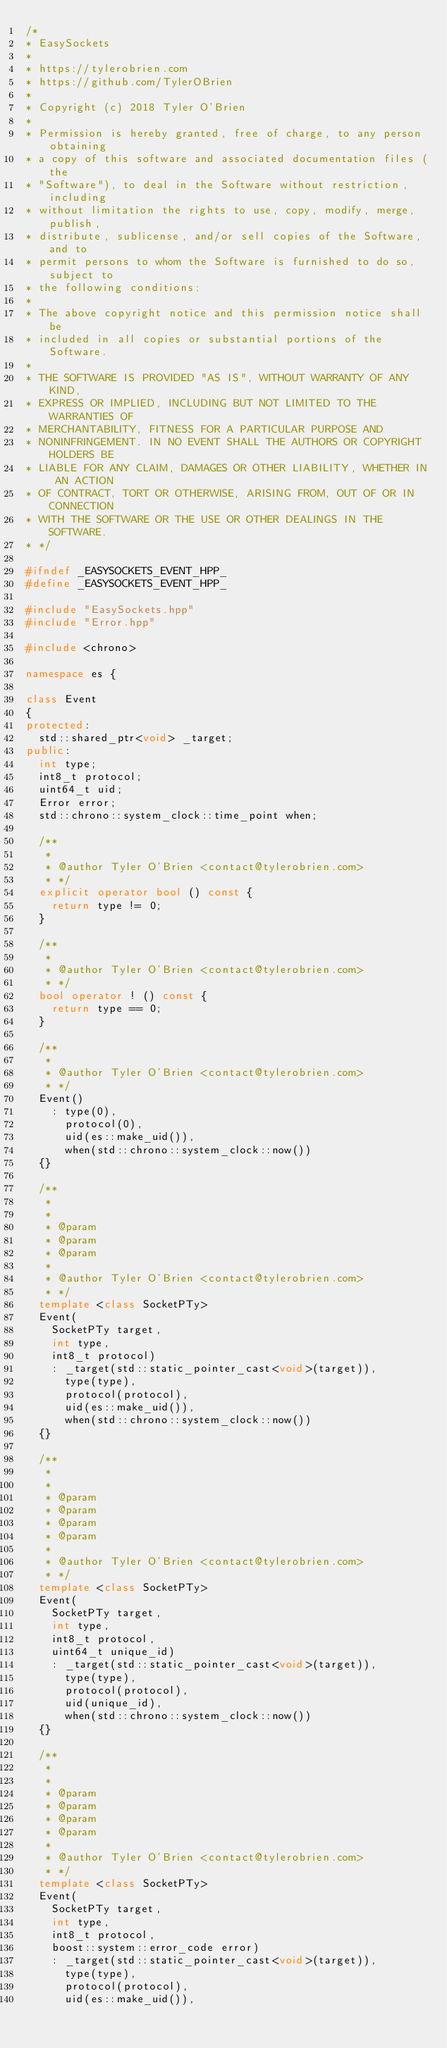Convert code to text. <code><loc_0><loc_0><loc_500><loc_500><_C++_>/*
* EasySockets
*
* https://tylerobrien.com
* https://github.com/TylerOBrien
*
* Copyright (c) 2018 Tyler O'Brien
*
* Permission is hereby granted, free of charge, to any person obtaining
* a copy of this software and associated documentation files (the
* "Software"), to deal in the Software without restriction, including
* without limitation the rights to use, copy, modify, merge, publish,
* distribute, sublicense, and/or sell copies of the Software, and to
* permit persons to whom the Software is furnished to do so, subject to
* the following conditions:
*
* The above copyright notice and this permission notice shall be
* included in all copies or substantial portions of the Software.
*
* THE SOFTWARE IS PROVIDED "AS IS", WITHOUT WARRANTY OF ANY KIND,
* EXPRESS OR IMPLIED, INCLUDING BUT NOT LIMITED TO THE WARRANTIES OF
* MERCHANTABILITY, FITNESS FOR A PARTICULAR PURPOSE AND
* NONINFRINGEMENT. IN NO EVENT SHALL THE AUTHORS OR COPYRIGHT HOLDERS BE
* LIABLE FOR ANY CLAIM, DAMAGES OR OTHER LIABILITY, WHETHER IN AN ACTION
* OF CONTRACT, TORT OR OTHERWISE, ARISING FROM, OUT OF OR IN CONNECTION
* WITH THE SOFTWARE OR THE USE OR OTHER DEALINGS IN THE SOFTWARE.
* */

#ifndef _EASYSOCKETS_EVENT_HPP_
#define _EASYSOCKETS_EVENT_HPP_

#include "EasySockets.hpp"
#include "Error.hpp"

#include <chrono>

namespace es {

class Event
{
protected:
  std::shared_ptr<void> _target;
public:
  int type;
  int8_t protocol;
  uint64_t uid;
  Error error;
  std::chrono::system_clock::time_point when;

  /**
   * 
   * @author Tyler O'Brien <contact@tylerobrien.com>
   * */
  explicit operator bool () const {
    return type != 0;
  }

  /**
   * 
   * @author Tyler O'Brien <contact@tylerobrien.com>
   * */
  bool operator ! () const {
    return type == 0;
  }

  /**
   * 
   * @author Tyler O'Brien <contact@tylerobrien.com>
   * */
  Event()
    : type(0),
      protocol(0),
      uid(es::make_uid()),
      when(std::chrono::system_clock::now())
  {}

  /**
   * 
   * 
   * @param
   * @param
   * @param
   * 
   * @author Tyler O'Brien <contact@tylerobrien.com>
   * */
  template <class SocketPTy>
  Event(
    SocketPTy target,
    int type,
    int8_t protocol)
    : _target(std::static_pointer_cast<void>(target)),
      type(type),
      protocol(protocol),
      uid(es::make_uid()),
      when(std::chrono::system_clock::now())
  {}

  /**
   * 
   * 
   * @param
   * @param
   * @param
   * @param
   * 
   * @author Tyler O'Brien <contact@tylerobrien.com>
   * */
  template <class SocketPTy>
  Event(
    SocketPTy target,
    int type,
    int8_t protocol,
    uint64_t unique_id)
    : _target(std::static_pointer_cast<void>(target)),
      type(type),
      protocol(protocol),
      uid(unique_id),
      when(std::chrono::system_clock::now())
  {}

  /**
   * 
   * 
   * @param
   * @param
   * @param
   * @param
   * 
   * @author Tyler O'Brien <contact@tylerobrien.com>
   * */
  template <class SocketPTy>
  Event(
    SocketPTy target,
    int type,
    int8_t protocol,
    boost::system::error_code error)
    : _target(std::static_pointer_cast<void>(target)),
      type(type),
      protocol(protocol),
      uid(es::make_uid()),</code> 